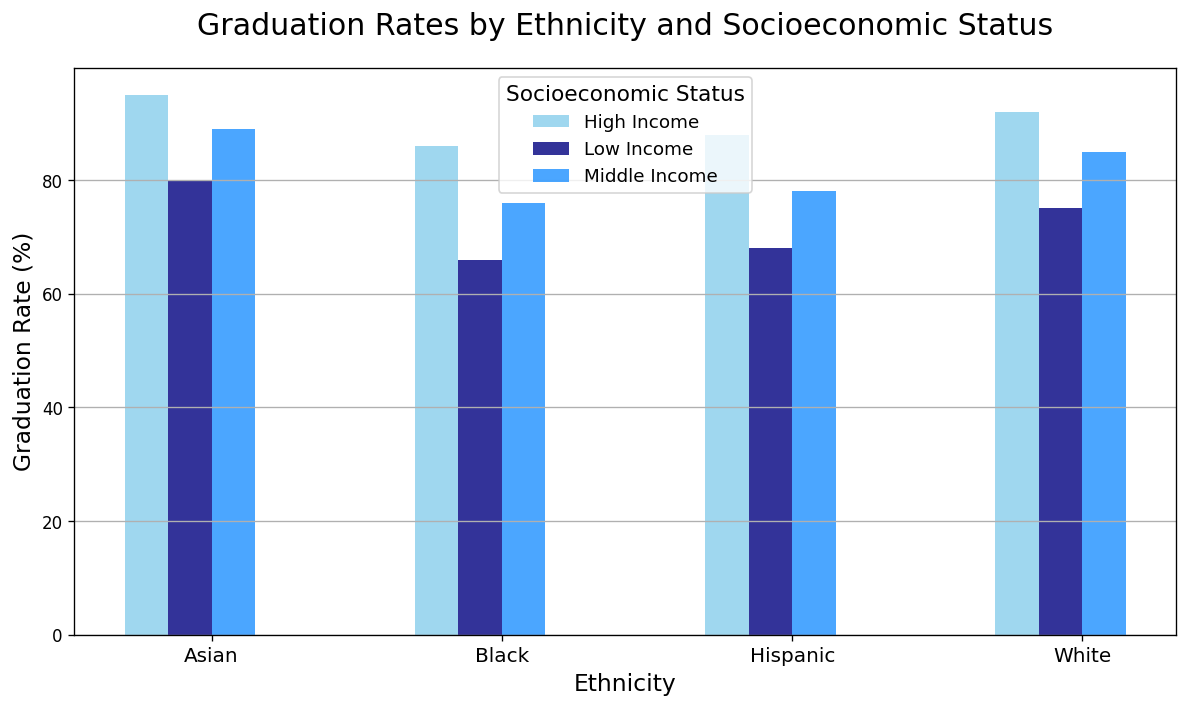What is the graduation rate for Asian students from a high-income socioeconomic status? The bar for Asian students from a high-income socioeconomic status shows a graduation rate of 95%.
Answer: 95% Which ethnicity has the lowest graduation rate among middle-income students? By comparing the bar heights across ethnicities under the middle-income category, Black students have the lowest graduation rate at 76%.
Answer: Black What is the difference in graduation rates between low-income and high-income Hispanic students? The graduation rate for low-income Hispanic students is 68%, and for high-income Hispanic students, it is 88%. The difference is 88% - 68% = 20%.
Answer: 20% Which socioeconomic status shows the highest graduation rates for all ethnicities overall? By looking at the bars' heights for each socioeconomic status across all ethnicities, the high-income status consistently shows the highest graduation rates.
Answer: High Income How does the graduation rate of middle-income White students compare to low-income Asian students? The graduation rate for middle-income White students is 85%, while for low-income Asian students it is 80%. Middle-income White students have a graduation rate that is 5% higher.
Answer: Middle-income White students have higher graduation rates Which group has the smallest difference in graduation rates between middle-income and low-income statuses? For each ethnicity, calculate the differences: White: 85% - 75% = 10%, Hispanic: 78% - 68% = 10%, Black: 76% - 66% = 10%, Asian: 89% - 80% = 9%. The smallest difference is for Asian students with 9%.
Answer: Asian (9%) What is the average graduation rate for high-income students across all ethnicities? Sum the graduation rates for high-income students: 92% (White) + 88% (Hispanic) + 86% (Black) + 95% (Asian) = 361%. Divide by the number of ethnicities (4): 361% / 4 = 90.25%.
Answer: 90.25% What is the overall trend in graduation rates as socioeconomic status decreases within each ethnicity? Observing all ethnicities, there is a consistent trend where graduation rates decrease from high-income to middle-income and further decrease from middle-income to low-income categories.
Answer: Rates decrease with lower socioeconomic status Which ethnic group has the highest graduation rate in the low-income category? By comparing the height of the bars for the low-income category across ethnicities, Asian students have the highest graduation rate at 80%.
Answer: Asian What is the median graduation rate for middle-income students across all ethnicities? The graduation rates for middle-income students are: White (85%), Hispanic (78%), Black (76%), and Asian (89%). Ordering them: 76%, 78%, 85%, 89%. The median is (78% + 85%) / 2 = 81.5%.
Answer: 81.5% 